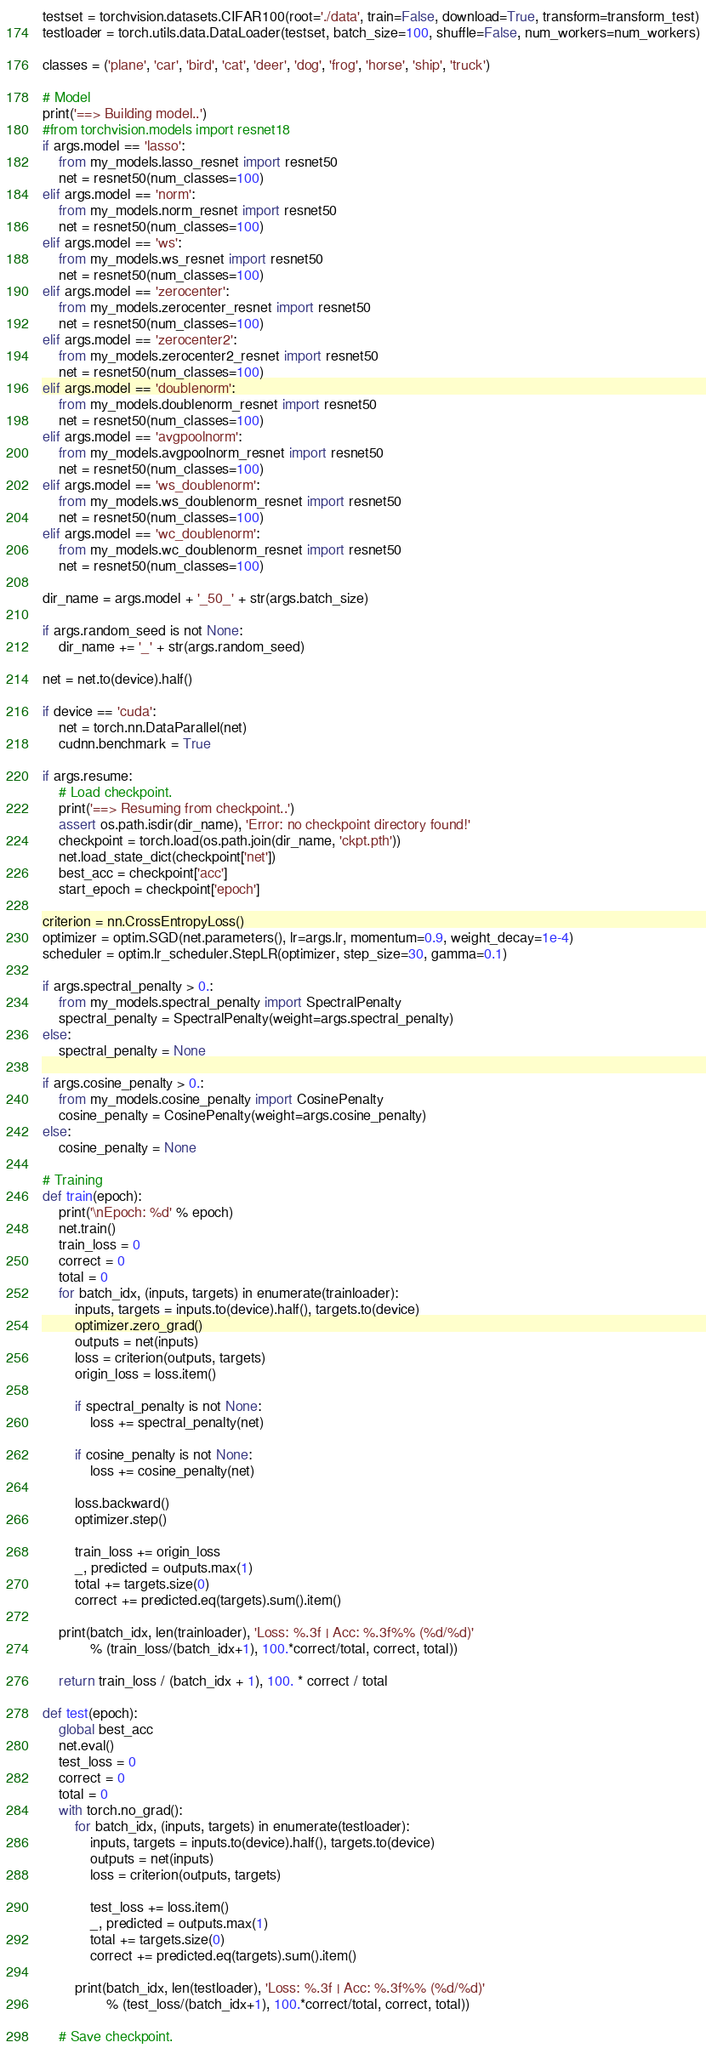Convert code to text. <code><loc_0><loc_0><loc_500><loc_500><_Python_>
testset = torchvision.datasets.CIFAR100(root='./data', train=False, download=True, transform=transform_test)
testloader = torch.utils.data.DataLoader(testset, batch_size=100, shuffle=False, num_workers=num_workers)

classes = ('plane', 'car', 'bird', 'cat', 'deer', 'dog', 'frog', 'horse', 'ship', 'truck')

# Model
print('==> Building model..')
#from torchvision.models import resnet18
if args.model == 'lasso':
    from my_models.lasso_resnet import resnet50
    net = resnet50(num_classes=100)
elif args.model == 'norm':
    from my_models.norm_resnet import resnet50
    net = resnet50(num_classes=100)
elif args.model == 'ws':
    from my_models.ws_resnet import resnet50
    net = resnet50(num_classes=100)
elif args.model == 'zerocenter':
    from my_models.zerocenter_resnet import resnet50
    net = resnet50(num_classes=100)
elif args.model == 'zerocenter2':
    from my_models.zerocenter2_resnet import resnet50
    net = resnet50(num_classes=100)
elif args.model == 'doublenorm':
    from my_models.doublenorm_resnet import resnet50
    net = resnet50(num_classes=100)
elif args.model == 'avgpoolnorm':
    from my_models.avgpoolnorm_resnet import resnet50
    net = resnet50(num_classes=100)
elif args.model == 'ws_doublenorm':
    from my_models.ws_doublenorm_resnet import resnet50
    net = resnet50(num_classes=100)
elif args.model == 'wc_doublenorm':
    from my_models.wc_doublenorm_resnet import resnet50
    net = resnet50(num_classes=100)

dir_name = args.model + '_50_' + str(args.batch_size)

if args.random_seed is not None:
    dir_name += '_' + str(args.random_seed)

net = net.to(device).half()

if device == 'cuda':
    net = torch.nn.DataParallel(net)
    cudnn.benchmark = True

if args.resume:
    # Load checkpoint.
    print('==> Resuming from checkpoint..')
    assert os.path.isdir(dir_name), 'Error: no checkpoint directory found!'
    checkpoint = torch.load(os.path.join(dir_name, 'ckpt.pth'))
    net.load_state_dict(checkpoint['net'])
    best_acc = checkpoint['acc']
    start_epoch = checkpoint['epoch']

criterion = nn.CrossEntropyLoss()
optimizer = optim.SGD(net.parameters(), lr=args.lr, momentum=0.9, weight_decay=1e-4)
scheduler = optim.lr_scheduler.StepLR(optimizer, step_size=30, gamma=0.1)

if args.spectral_penalty > 0.:
    from my_models.spectral_penalty import SpectralPenalty
    spectral_penalty = SpectralPenalty(weight=args.spectral_penalty)
else:
    spectral_penalty = None

if args.cosine_penalty > 0.:
    from my_models.cosine_penalty import CosinePenalty
    cosine_penalty = CosinePenalty(weight=args.cosine_penalty)
else:
    cosine_penalty = None

# Training
def train(epoch):
    print('\nEpoch: %d' % epoch)
    net.train()
    train_loss = 0
    correct = 0
    total = 0
    for batch_idx, (inputs, targets) in enumerate(trainloader):
        inputs, targets = inputs.to(device).half(), targets.to(device)
        optimizer.zero_grad()
        outputs = net(inputs)
        loss = criterion(outputs, targets)
        origin_loss = loss.item()

        if spectral_penalty is not None:
            loss += spectral_penalty(net)
        
        if cosine_penalty is not None:
            loss += cosine_penalty(net)

        loss.backward()
        optimizer.step()

        train_loss += origin_loss
        _, predicted = outputs.max(1)
        total += targets.size(0)
        correct += predicted.eq(targets).sum().item()

    print(batch_idx, len(trainloader), 'Loss: %.3f | Acc: %.3f%% (%d/%d)'
            % (train_loss/(batch_idx+1), 100.*correct/total, correct, total))
    
    return train_loss / (batch_idx + 1), 100. * correct / total

def test(epoch):
    global best_acc
    net.eval()
    test_loss = 0
    correct = 0
    total = 0
    with torch.no_grad():
        for batch_idx, (inputs, targets) in enumerate(testloader):
            inputs, targets = inputs.to(device).half(), targets.to(device)
            outputs = net(inputs)
            loss = criterion(outputs, targets)

            test_loss += loss.item()
            _, predicted = outputs.max(1)
            total += targets.size(0)
            correct += predicted.eq(targets).sum().item()

        print(batch_idx, len(testloader), 'Loss: %.3f | Acc: %.3f%% (%d/%d)'
                % (test_loss/(batch_idx+1), 100.*correct/total, correct, total))

    # Save checkpoint.</code> 